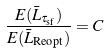Convert formula to latex. <formula><loc_0><loc_0><loc_500><loc_500>\frac { E ( \bar { L } _ { \tau _ { \text {sf} } } ) } { E ( \bar { L } _ { \text {Reopt} } ) } = C</formula> 